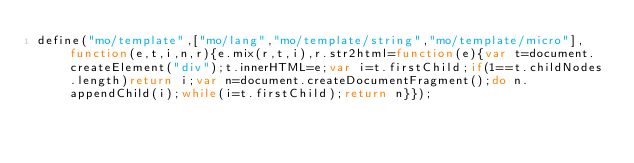Convert code to text. <code><loc_0><loc_0><loc_500><loc_500><_JavaScript_>define("mo/template",["mo/lang","mo/template/string","mo/template/micro"],function(e,t,i,n,r){e.mix(r,t,i),r.str2html=function(e){var t=document.createElement("div");t.innerHTML=e;var i=t.firstChild;if(1==t.childNodes.length)return i;var n=document.createDocumentFragment();do n.appendChild(i);while(i=t.firstChild);return n}});</code> 